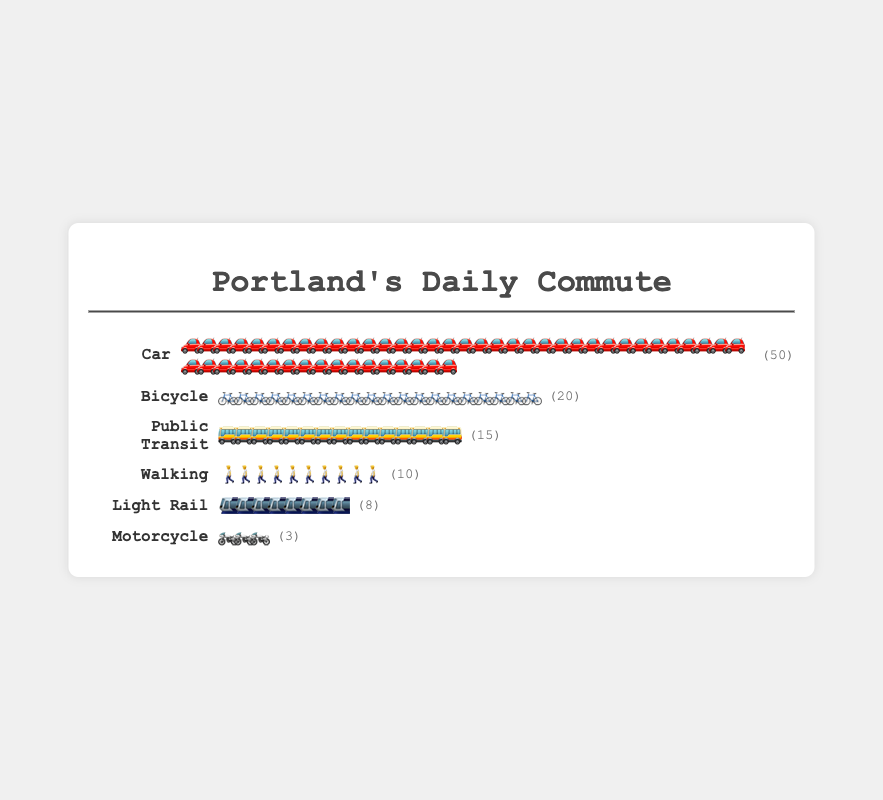What is the most common transportation mode for daily commutes in Portland? The most common transportation mode is the one with the largest number of icons in the plot. In this plot, the "Car" mode has the most icons (50).
Answer: Car How many more people use bicycles compared to motorcycles for their daily commutes? To find this, subtract the count of motorcycles from the count of bicycles: 20 bicycles - 3 motorcycles = 17.
Answer: 17 Which transportation mode is used by the fewest people for their daily commutes? The transportation mode with the least number of icons represents the fewest users. In this plot, the "Motorcycle" mode has only 3 icons.
Answer: Motorcycle What percentage of people use public transit for their daily commutes out of the total provided in the plot? First, calculate the total number of people: 50 (Car) + 20 (Bicycle) + 15 (Public Transit) + 10 (Walking) + 8 (Light Rail) + 3 (Motorcycle) = 106. Then calculate the percentage for Public Transit: (15 / 106) * 100 ≈ 14.15%.
Answer: Approximately 14.15% What is the combined total number of people who commute using either walking or light rail? Add the counts for walking and light rail: 10 (Walking) + 8 (Light Rail) = 18.
Answer: 18 Which is the second most popular transportation mode for daily commutes? The second most popular mode is the one with the second-highest number of icons. In this plot, the "Bicycle" mode has 20 icons, which is second only to "Car".
Answer: Bicycle Are there more people using light rail or motorcycles for their daily commutes? Compare the number of icons for Light Rail (8) and Motorcycles (3). 8 is greater than 3.
Answer: Light Rail What is the difference in the number of people using public transit versus walking? Subtract the number of people using walking from the number using public transit: 15 (Public Transit) - 10 (Walking) = 5.
Answer: 5 What is the sum of people using non-motorized transportation modes (bicycle and walking)? Add the counts for bicycles and walking: 20 (Bicycle) + 10 (Walking) = 30.
Answer: 30 Which transportation modes have a single-digit count of users? Identify the modes with counts less than 10: Light Rail (8) and Motorcycle (3).
Answer: Light Rail, Motorcycle 